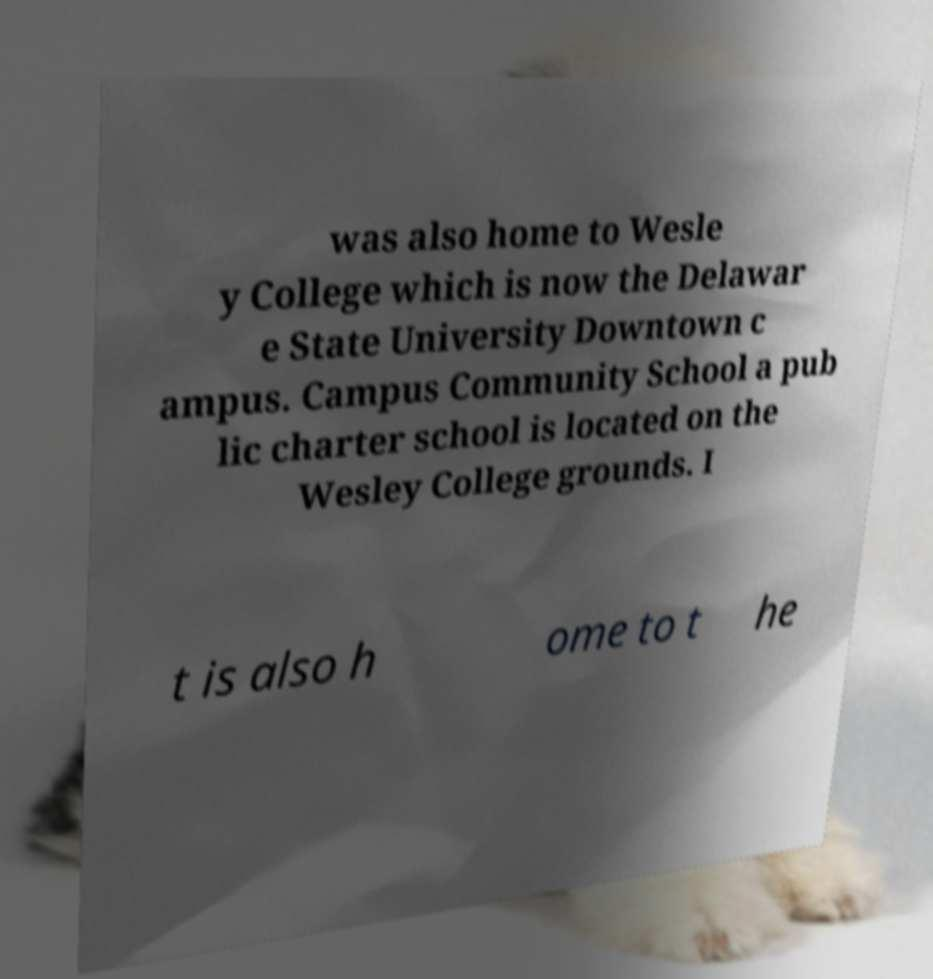Please identify and transcribe the text found in this image. was also home to Wesle y College which is now the Delawar e State University Downtown c ampus. Campus Community School a pub lic charter school is located on the Wesley College grounds. I t is also h ome to t he 